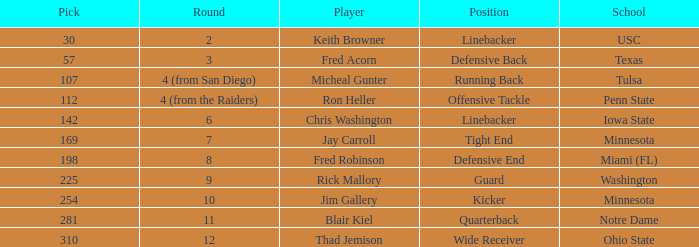What is the overall selection number from the second round? 1.0. 